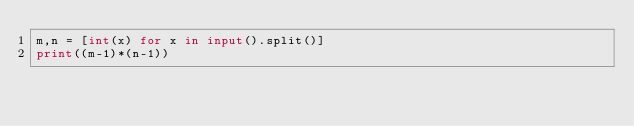<code> <loc_0><loc_0><loc_500><loc_500><_Python_>m,n = [int(x) for x in input().split()]
print((m-1)*(n-1))</code> 